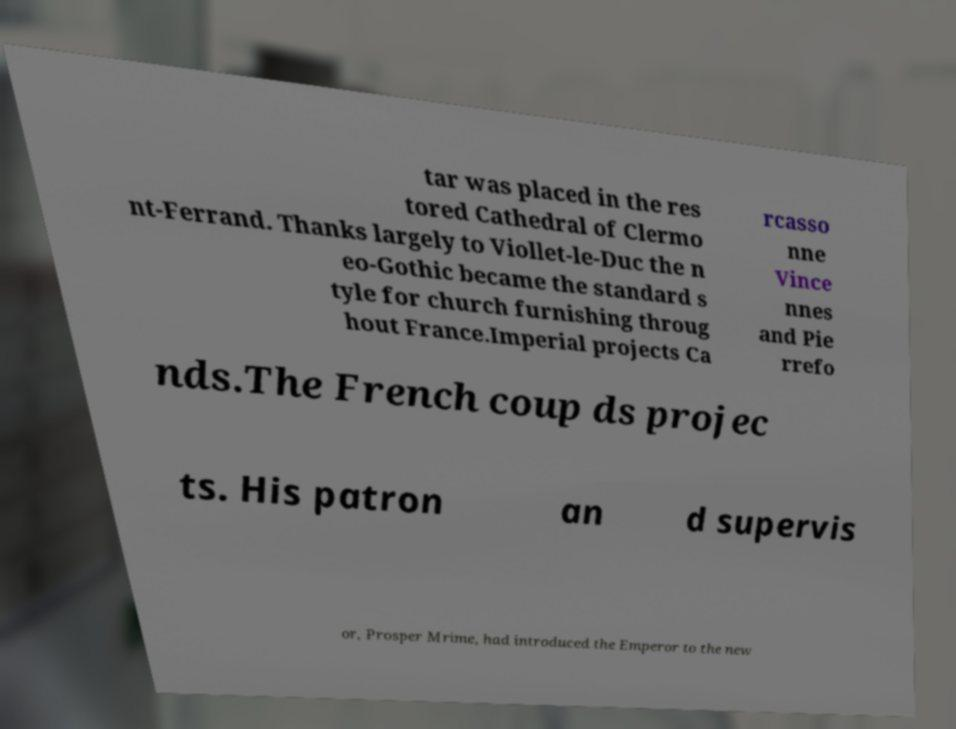There's text embedded in this image that I need extracted. Can you transcribe it verbatim? tar was placed in the res tored Cathedral of Clermo nt-Ferrand. Thanks largely to Viollet-le-Duc the n eo-Gothic became the standard s tyle for church furnishing throug hout France.Imperial projects Ca rcasso nne Vince nnes and Pie rrefo nds.The French coup ds projec ts. His patron an d supervis or, Prosper Mrime, had introduced the Emperor to the new 